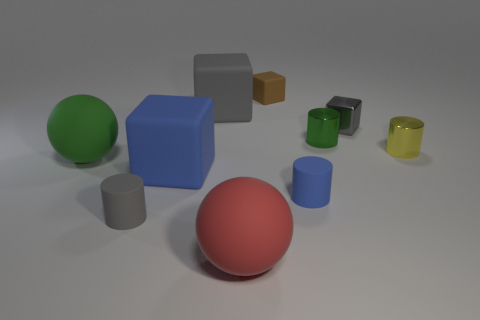How many gray blocks must be subtracted to get 1 gray blocks? 1 Subtract all blue matte cylinders. How many cylinders are left? 3 Subtract all spheres. How many objects are left? 8 Subtract all gray cubes. How many cubes are left? 2 Subtract 0 cyan cylinders. How many objects are left? 10 Subtract 4 blocks. How many blocks are left? 0 Subtract all purple cylinders. Subtract all blue balls. How many cylinders are left? 4 Subtract all yellow cubes. How many gray balls are left? 0 Subtract all large red rubber balls. Subtract all small brown rubber spheres. How many objects are left? 9 Add 8 green spheres. How many green spheres are left? 9 